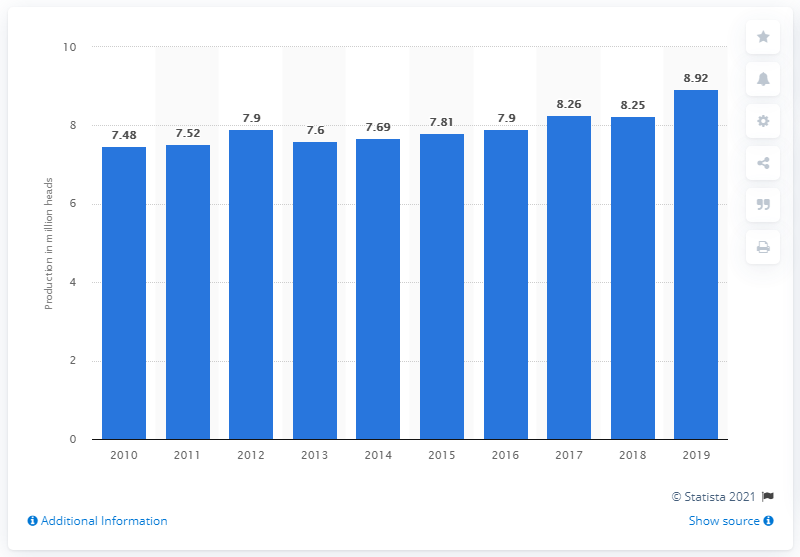Mention a couple of crucial points in this snapshot. In 2019, a total of 8.92 million pigs were produced in Indonesia. 